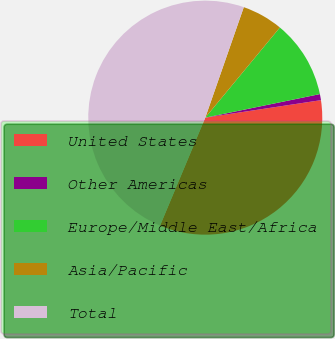Convert chart. <chart><loc_0><loc_0><loc_500><loc_500><pie_chart><fcel>United States<fcel>Other Americas<fcel>Europe/Middle East/Africa<fcel>Asia/Pacific<fcel>Total<nl><fcel>33.7%<fcel>0.84%<fcel>10.77%<fcel>5.66%<fcel>49.03%<nl></chart> 